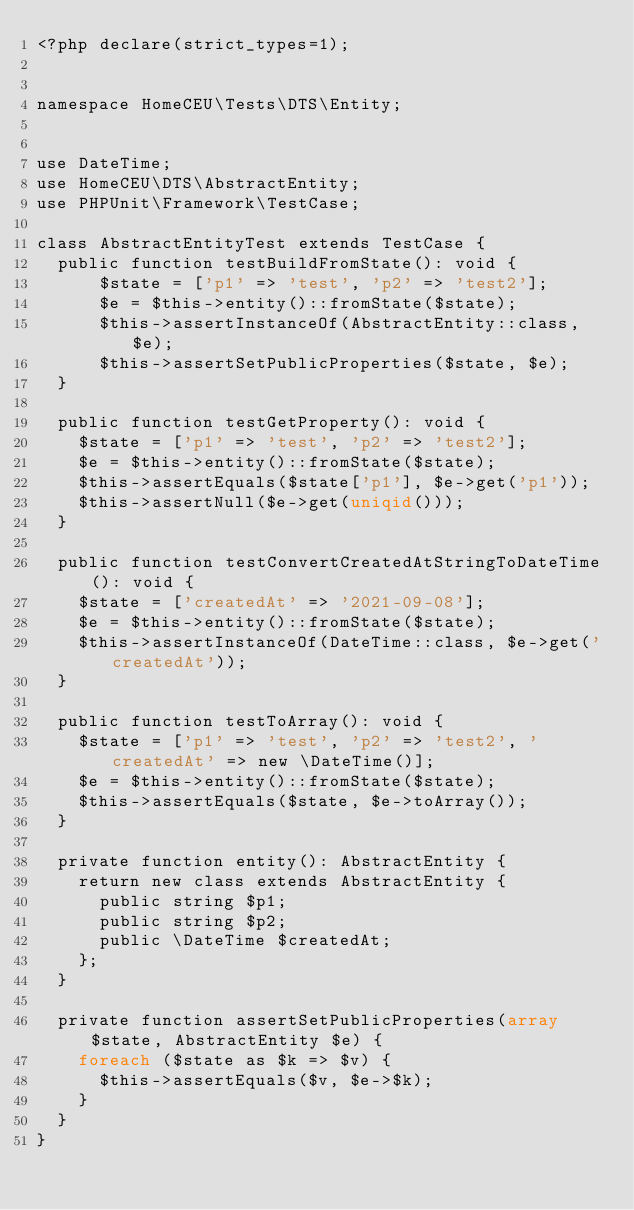Convert code to text. <code><loc_0><loc_0><loc_500><loc_500><_PHP_><?php declare(strict_types=1);


namespace HomeCEU\Tests\DTS\Entity;


use DateTime;
use HomeCEU\DTS\AbstractEntity;
use PHPUnit\Framework\TestCase;

class AbstractEntityTest extends TestCase {
  public function testBuildFromState(): void {
      $state = ['p1' => 'test', 'p2' => 'test2'];
      $e = $this->entity()::fromState($state);
      $this->assertInstanceOf(AbstractEntity::class, $e);
      $this->assertSetPublicProperties($state, $e);
  }

  public function testGetProperty(): void {
    $state = ['p1' => 'test', 'p2' => 'test2'];
    $e = $this->entity()::fromState($state);
    $this->assertEquals($state['p1'], $e->get('p1'));
    $this->assertNull($e->get(uniqid()));
  }

  public function testConvertCreatedAtStringToDateTime(): void {
    $state = ['createdAt' => '2021-09-08'];
    $e = $this->entity()::fromState($state);
    $this->assertInstanceOf(DateTime::class, $e->get('createdAt'));
  }

  public function testToArray(): void {
    $state = ['p1' => 'test', 'p2' => 'test2', 'createdAt' => new \DateTime()];
    $e = $this->entity()::fromState($state);
    $this->assertEquals($state, $e->toArray());
  }

  private function entity(): AbstractEntity {
    return new class extends AbstractEntity {
      public string $p1;
      public string $p2;
      public \DateTime $createdAt;
    };
  }

  private function assertSetPublicProperties(array $state, AbstractEntity $e) {
    foreach ($state as $k => $v) {
      $this->assertEquals($v, $e->$k);
    }
  }
}
</code> 